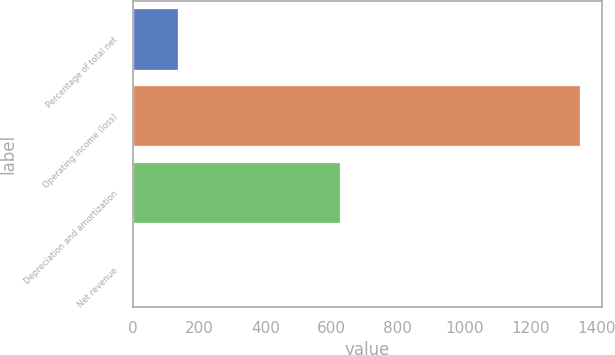Convert chart to OTSL. <chart><loc_0><loc_0><loc_500><loc_500><bar_chart><fcel>Percentage of total net<fcel>Operating income (loss)<fcel>Depreciation and amortization<fcel>Net revenue<nl><fcel>135.8<fcel>1349<fcel>625<fcel>1<nl></chart> 